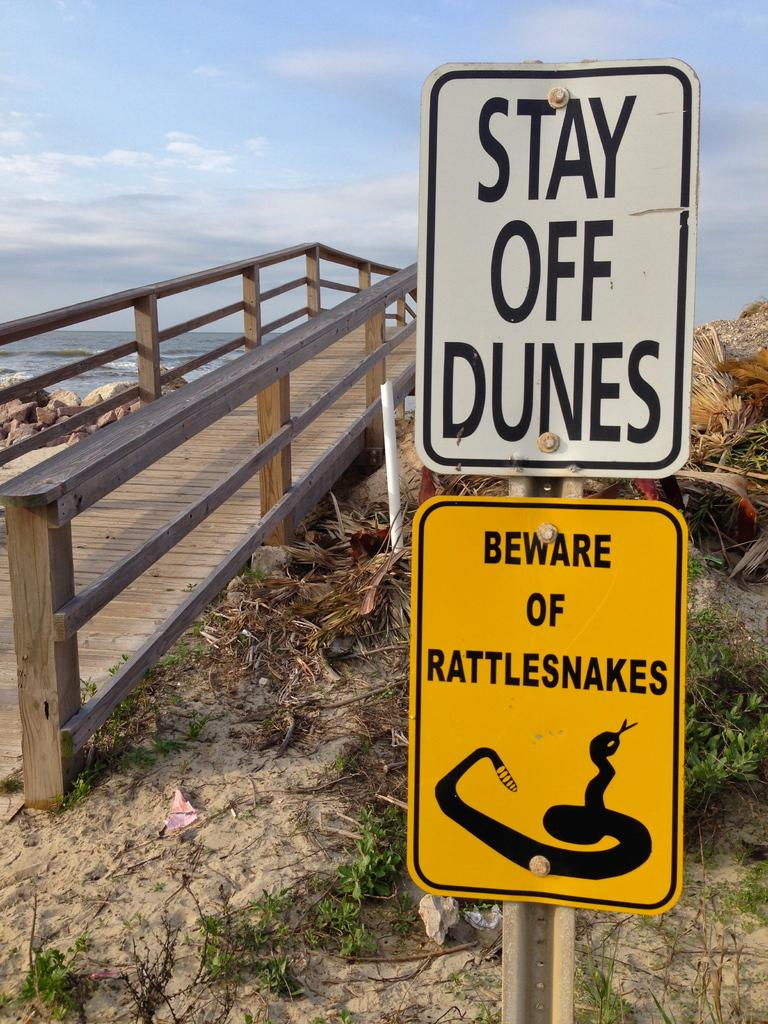<image>
Share a concise interpretation of the image provided. Signs on the side of a beach boardwalk that warn to stay off the dunes and beware of rattlesnakes. 